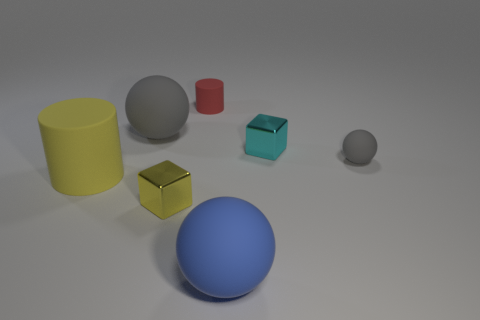How many objects are there in total and can you describe their arrangement? In the image, there are a total of six objects arranged on a surface. From left to right, there is a yellow cylinder, a large grey sphere, a small red cylinder, a teal cube, a yellow cube, and a small grey sphere. 